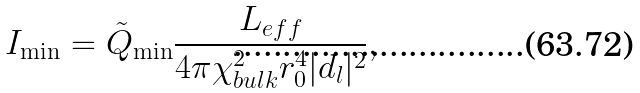<formula> <loc_0><loc_0><loc_500><loc_500>I _ { \min } = \tilde { Q } _ { \min } \frac { L _ { e f f } } { 4 \pi \chi ^ { 2 } _ { b u l k } r _ { 0 } ^ { 4 } | d _ { l } | ^ { 2 } } ,</formula> 